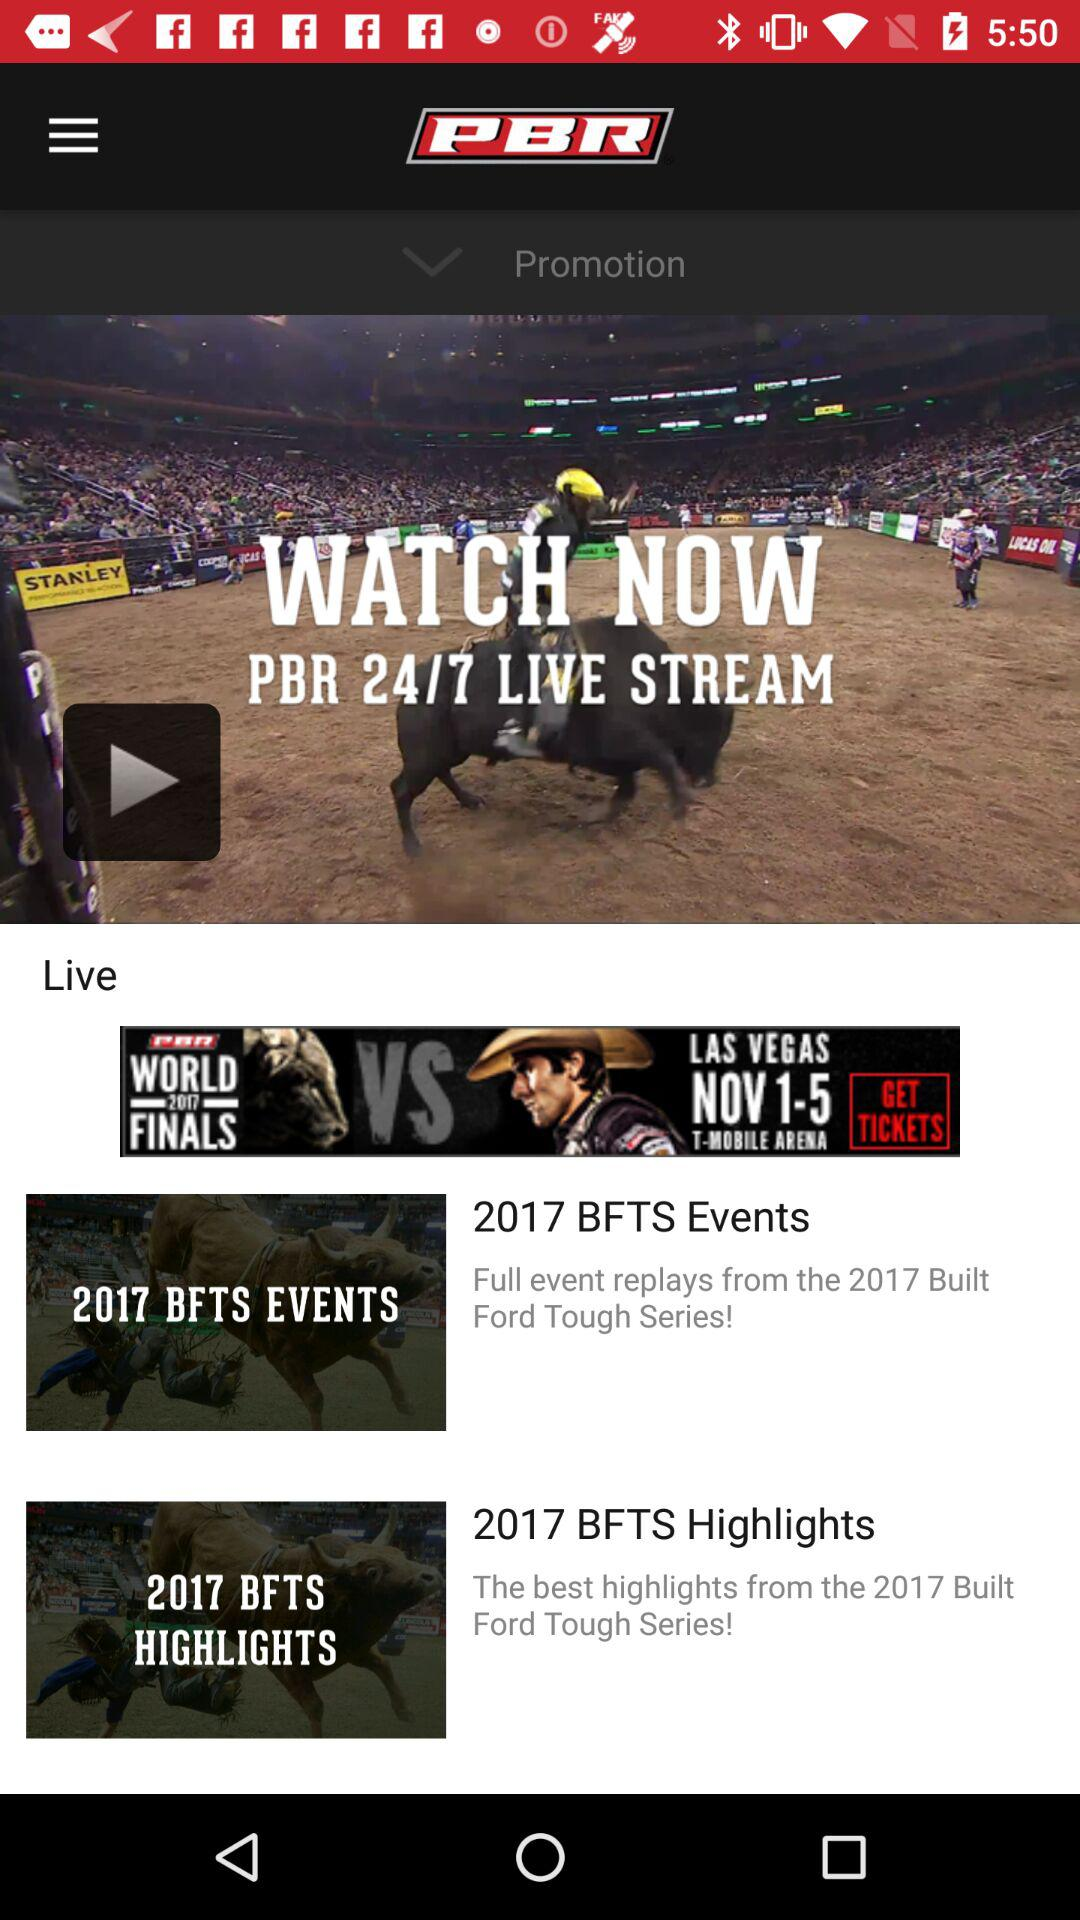What is the year of the BFTS events? The year of the BFTS events is 2017. 